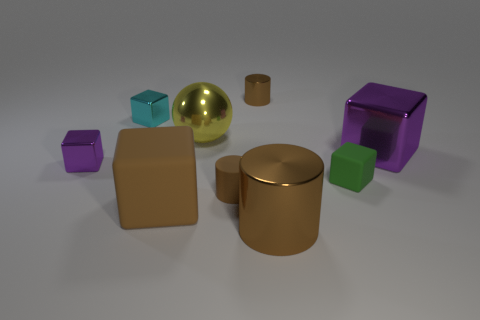Subtract all brown cylinders. How many were subtracted if there are1brown cylinders left? 2 Subtract all small cylinders. How many cylinders are left? 1 Subtract all cyan blocks. How many blocks are left? 4 Subtract 2 cubes. How many cubes are left? 3 Subtract all green cylinders. How many red spheres are left? 0 Add 5 metal cylinders. How many metal cylinders exist? 7 Subtract 0 gray cubes. How many objects are left? 9 Subtract all blocks. How many objects are left? 4 Subtract all purple cylinders. Subtract all cyan spheres. How many cylinders are left? 3 Subtract all yellow objects. Subtract all yellow things. How many objects are left? 7 